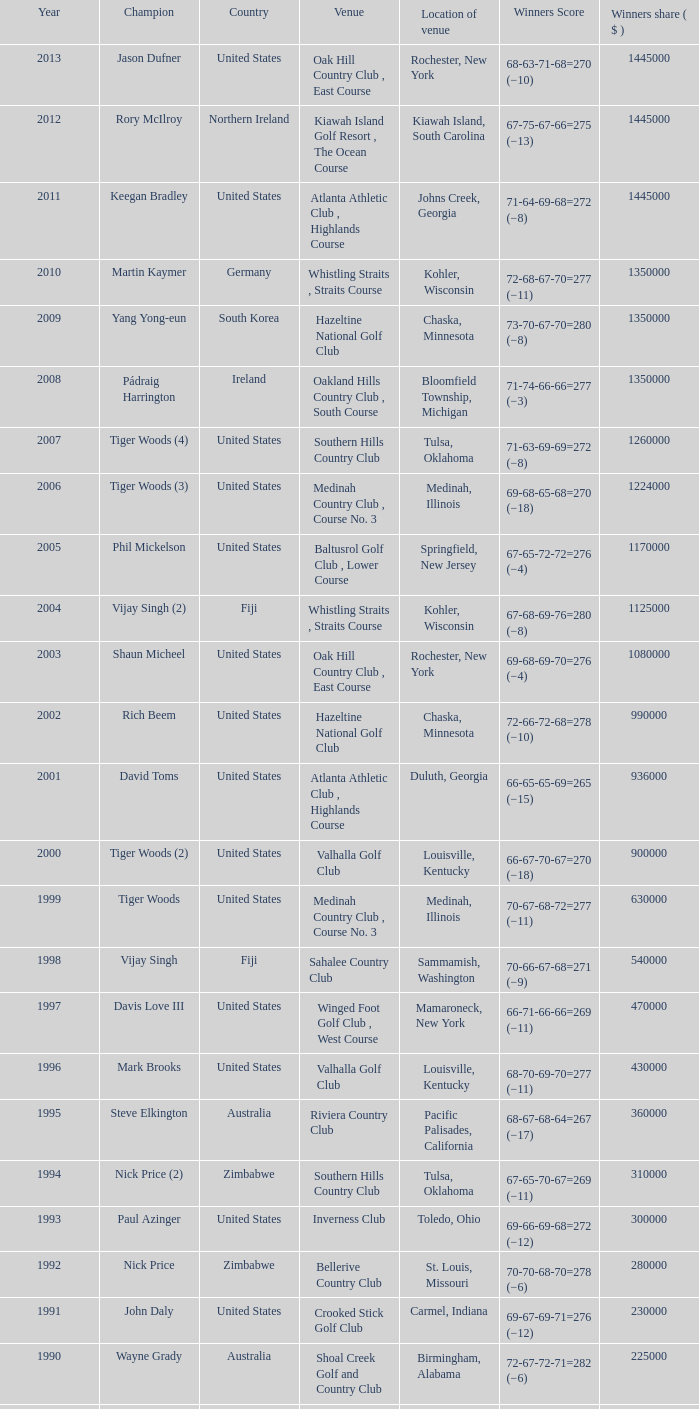What is the location of the bellerive country club venue? St. Louis, Missouri. 